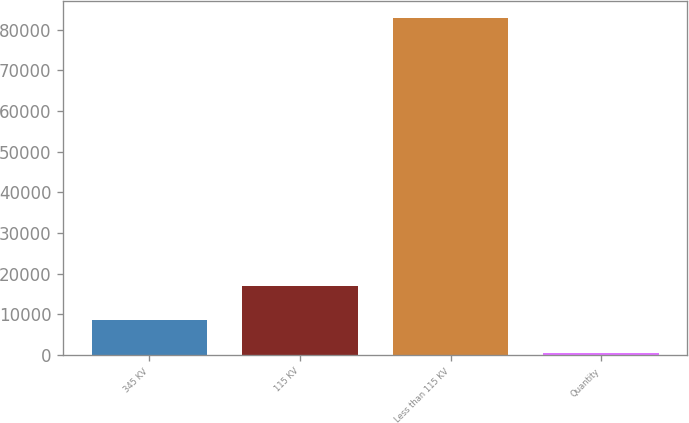Convert chart. <chart><loc_0><loc_0><loc_500><loc_500><bar_chart><fcel>345 KV<fcel>115 KV<fcel>Less than 115 KV<fcel>Quantity<nl><fcel>8615.7<fcel>16856.4<fcel>82782<fcel>375<nl></chart> 